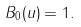Convert formula to latex. <formula><loc_0><loc_0><loc_500><loc_500>B _ { 0 } ( u ) = 1 .</formula> 